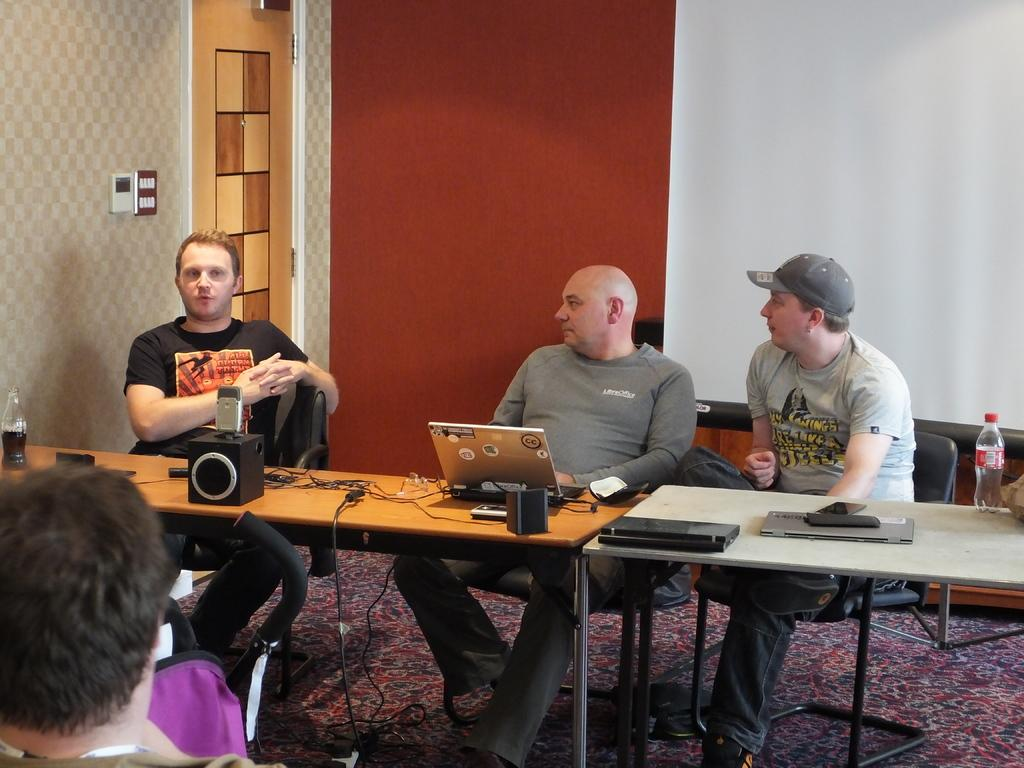How many men are in the image? There are three men in the image. What are the men doing in the image? The men are sitting on chairs. Where are the chairs located in relation to the table? The chairs are in front of the table. What electronic devices are on the table? There is a laptop and a speaker on the table. What can be seen on the table for hydration purposes? There is a water bottle on the table. What is visible in the background on the left side? There is a door visible in the background on the left side. What type of tail can be seen on the laptop in the image? There is no tail present on the laptop in the image. Is there a doctor in the image providing medical assistance to the men? There is no doctor present in the image, and the men are not receiving any medical assistance. 